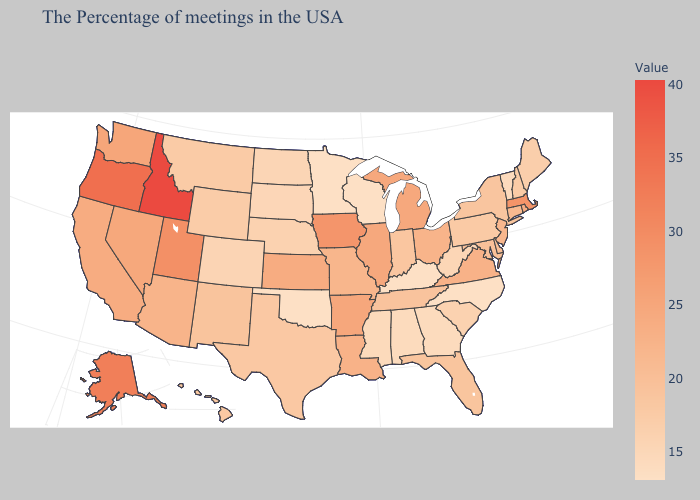Does Alaska have the highest value in the USA?
Concise answer only. No. Does Georgia have the lowest value in the South?
Give a very brief answer. No. Among the states that border Kansas , does Oklahoma have the lowest value?
Answer briefly. Yes. Among the states that border Montana , which have the highest value?
Concise answer only. Idaho. Among the states that border Texas , which have the lowest value?
Be succinct. Oklahoma. 